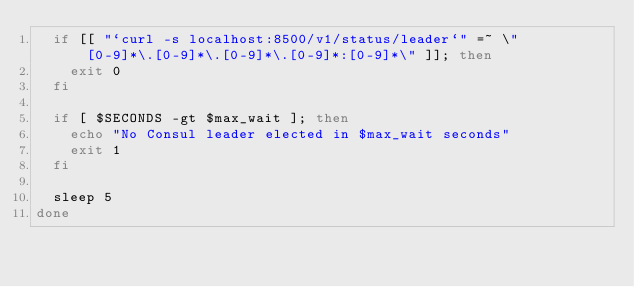<code> <loc_0><loc_0><loc_500><loc_500><_Bash_>  if [[ "`curl -s localhost:8500/v1/status/leader`" =~ \"[0-9]*\.[0-9]*\.[0-9]*\.[0-9]*:[0-9]*\" ]]; then
    exit 0
  fi

  if [ $SECONDS -gt $max_wait ]; then
    echo "No Consul leader elected in $max_wait seconds"
    exit 1
  fi

  sleep 5
done
</code> 